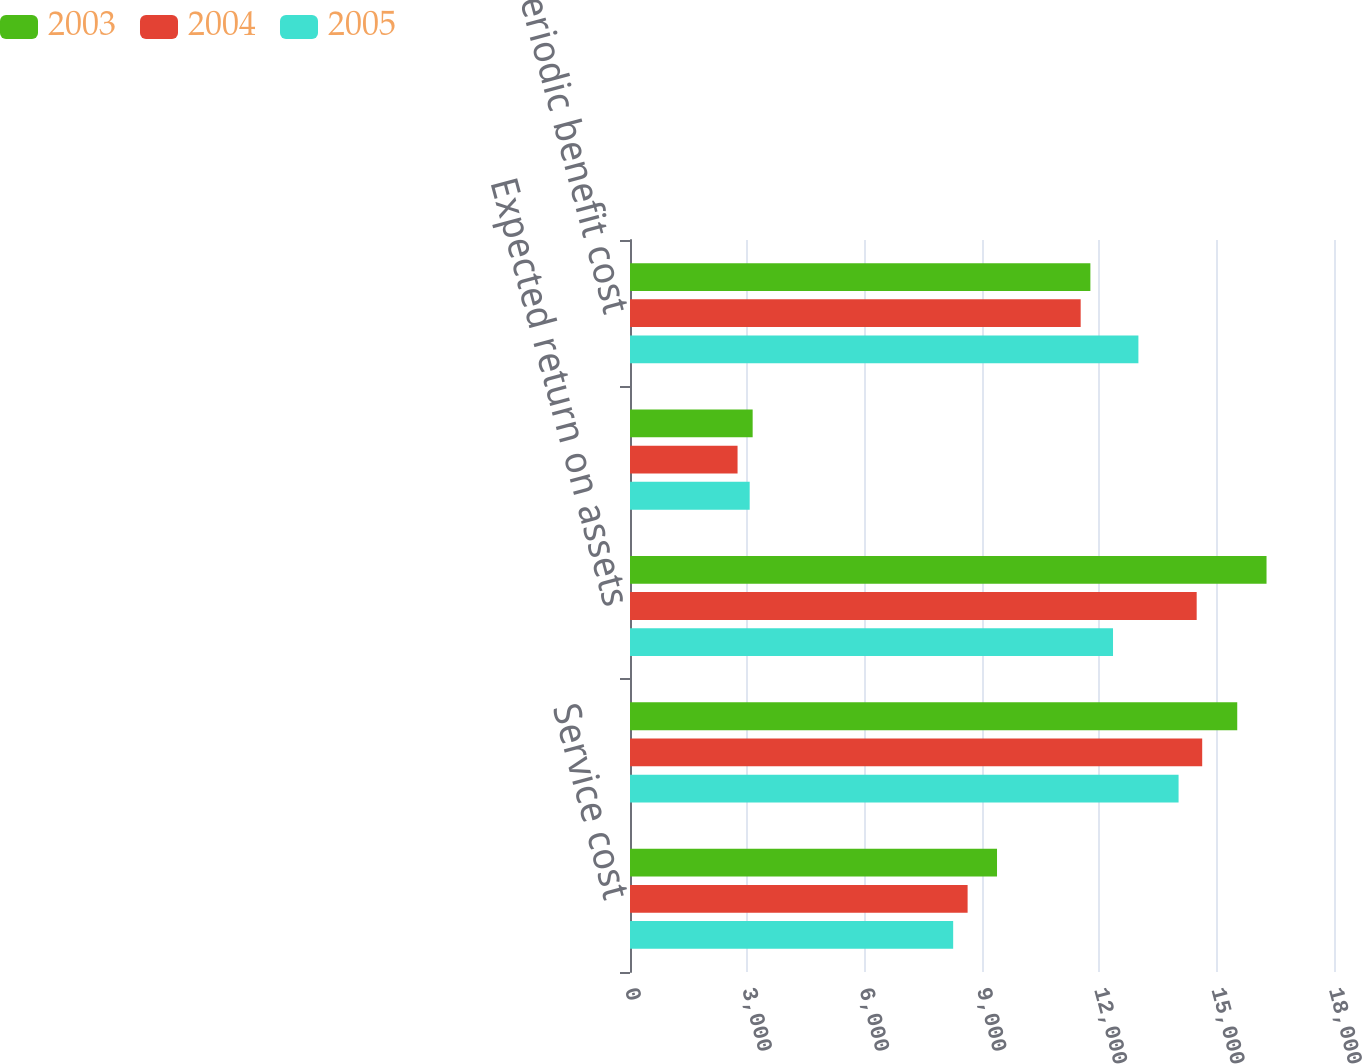Convert chart. <chart><loc_0><loc_0><loc_500><loc_500><stacked_bar_chart><ecel><fcel>Service cost<fcel>Interest cost<fcel>Expected return on assets<fcel>Net amortization and deferrals<fcel>Net periodic benefit cost<nl><fcel>2003<fcel>9384<fcel>15526<fcel>16275<fcel>3136<fcel>11771<nl><fcel>2004<fcel>8632<fcel>14630<fcel>14489<fcel>2750<fcel>11523<nl><fcel>2005<fcel>8263<fcel>14026<fcel>12350<fcel>3060<fcel>12999<nl></chart> 